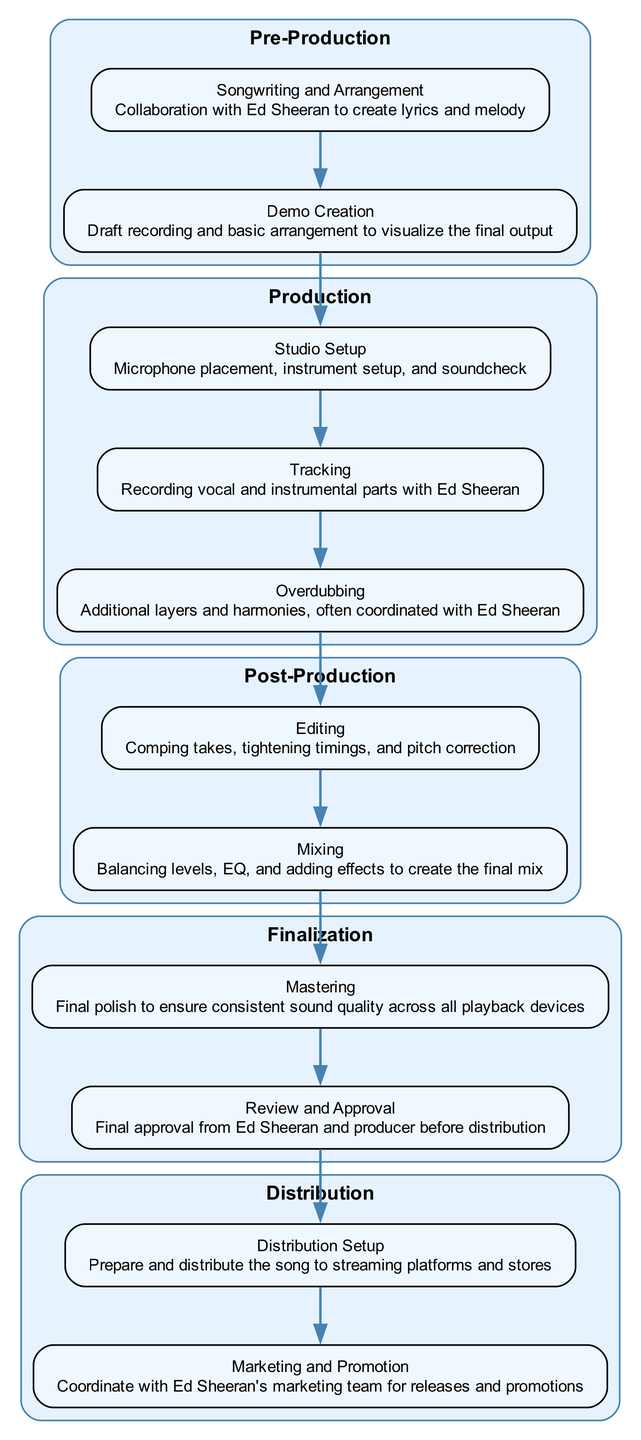What are the two main stages in the workflow? The diagram shows five distinct stages: Pre-Production, Production, Post-Production, Finalization, and Distribution. However, the two main stages of recording a hit song can be considered as 'Production' and 'Post-Production.'
Answer: Production, Post-Production How many elements are in the 'Production' stage? The 'Production' stage includes three elements: Studio Setup, Tracking, and Overdubbing. Each of these is clearly shown as part of this stage in the diagram.
Answer: 3 What is the last step before distribution? The last step before moving to the Distribution stage is the Review and Approval step in the Finalization stage. This indicates it is a critical check before the song goes out to the public.
Answer: Review and Approval Which stage has the most elements? By reviewing the elements in each stage, we can see that the 'Production' stage with its three elements is the stage with the most elements. The others contain fewer elements.
Answer: Production What connects 'Editing' and 'Mixing' in the diagram? In the diagram, 'Editing' and 'Mixing' are connected by a direct edge, indicating that after editing the recorded sections, mixing follows as the next logical step in the workflow.
Answer: An edge means a connection How does 'Marketing and Promotion' relate to 'Distribution Setup'? In the workflow, 'Marketing and Promotion' follows 'Distribution Setup', indicating it is part of the overall process to launch the song. Hence, it directly depends on the setup of distribution for effective marketing.
Answer: It follows Distribution Setup How many edges are there in the diagram? By counting the connections (edges) between the various stages and elements, there are six edges that show the workflow or the flow of the tasks involved in recording a hit song.
Answer: 6 What is the function of the 'Mastering' element? The 'Mastering' element's function is to provide a final polish to the song, ensuring that it sounds consistent across all playback devices, which is crucial in the final stages of the recording process.
Answer: Final polish Which element indicates collaboration with Ed Sheeran? The 'Tracking' and 'Overdubbing' elements in the 'Production' stage both involve collaboration with Ed Sheeran, emphasizing his integral role in these processes as part of the recording workflow.
Answer: Tracking, Overdubbing What is the first element in the 'Pre-Production' stage? The first element listed in the 'Pre-Production' stage is 'Songwriting and Arrangement', which indicates it is the foundational step in developing the song before recording begins.
Answer: Songwriting and Arrangement 